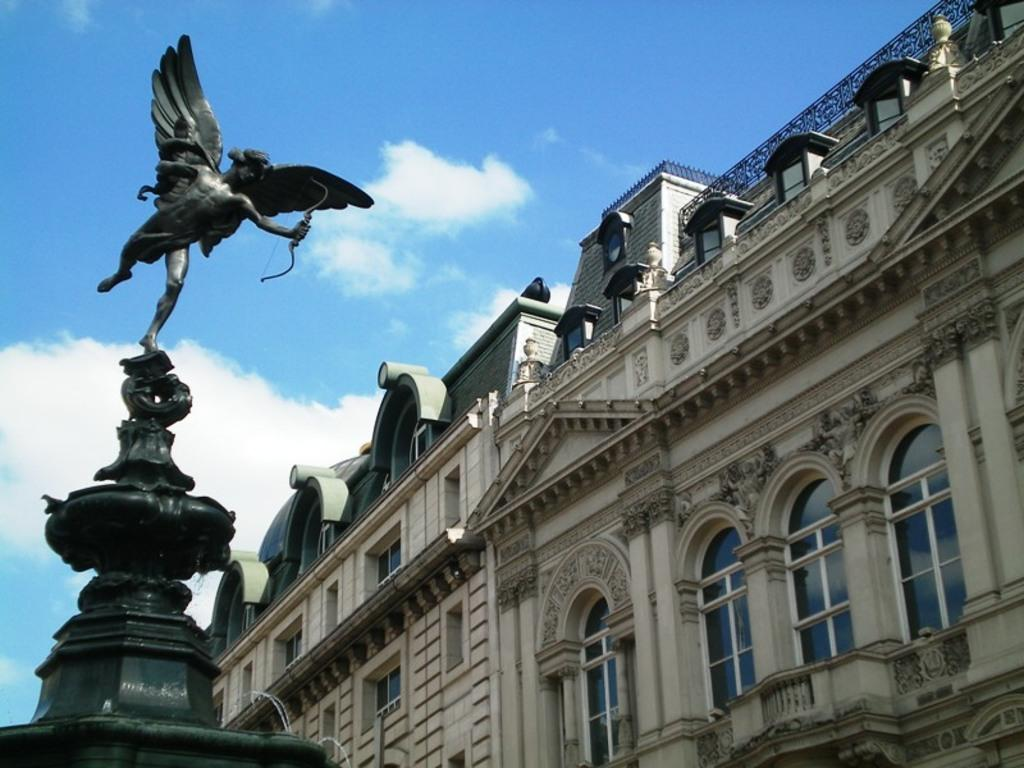What is the main subject of the image? The main subject of the image is a sculpture of a human being with wings. What is the sculpture holding in its hands? The sculpture is holding an archer in its hands. What can be seen on the right side of the image? There is a building on the right side of the image. What is visible at the top of the image? The sky is visible at the top of the image. How many crackers are placed on the sculpture's head in the image? There are no crackers present in the image; it features a sculpture of a human being with wings holding an archer. What type of sign is visible on the building in the image? There is no sign visible on the building in the image; only the building itself is present. 